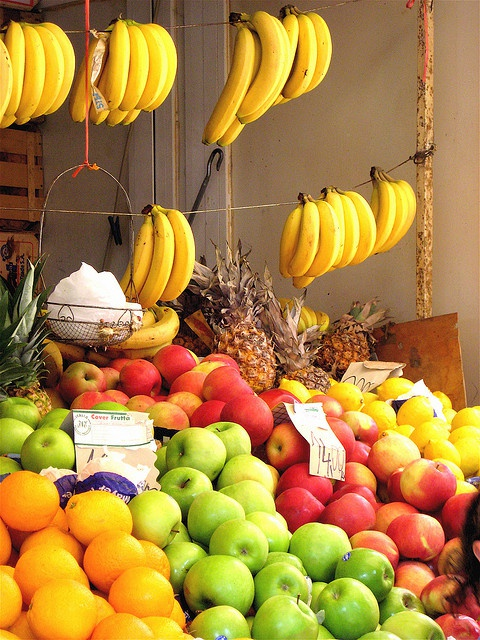Describe the objects in this image and their specific colors. I can see apple in maroon, red, brown, and salmon tones, apple in maroon, yellow, olive, and khaki tones, banana in maroon, gold, orange, yellow, and olive tones, banana in maroon, orange, gold, and olive tones, and banana in maroon, yellow, gold, orange, and olive tones in this image. 